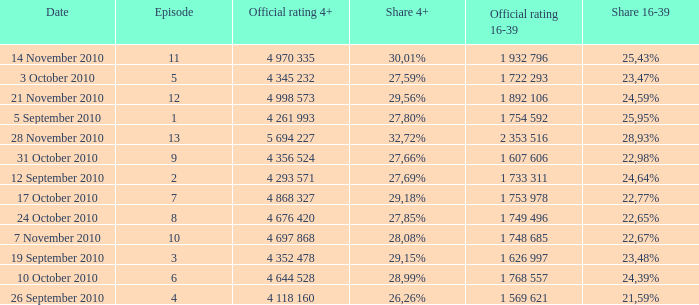What is the official rating 16-39 for the episode with  a 16-39 share of 22,77%? 1 753 978. 